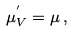Convert formula to latex. <formula><loc_0><loc_0><loc_500><loc_500>\mu ^ { ^ { \prime } } _ { V } = \mu \, ,</formula> 